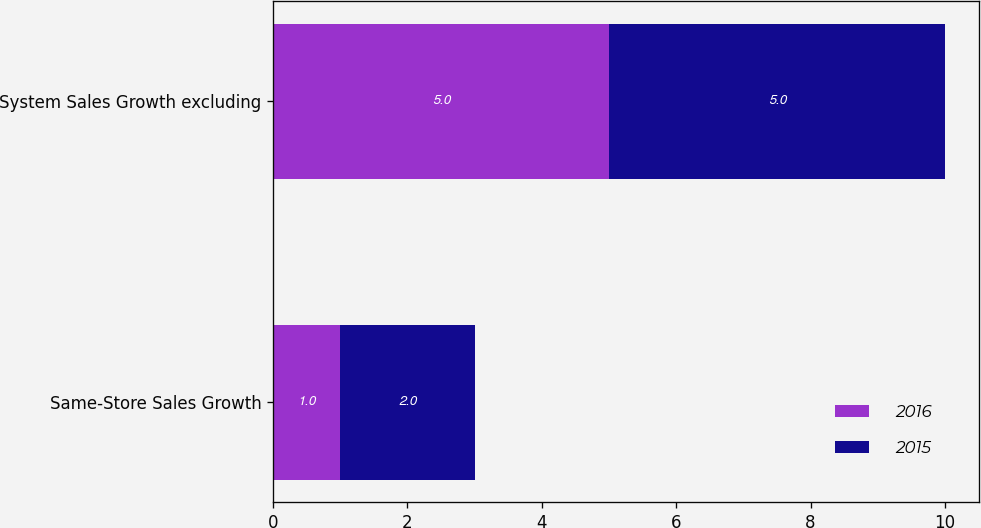<chart> <loc_0><loc_0><loc_500><loc_500><stacked_bar_chart><ecel><fcel>Same-Store Sales Growth<fcel>System Sales Growth excluding<nl><fcel>2016<fcel>1<fcel>5<nl><fcel>2015<fcel>2<fcel>5<nl></chart> 